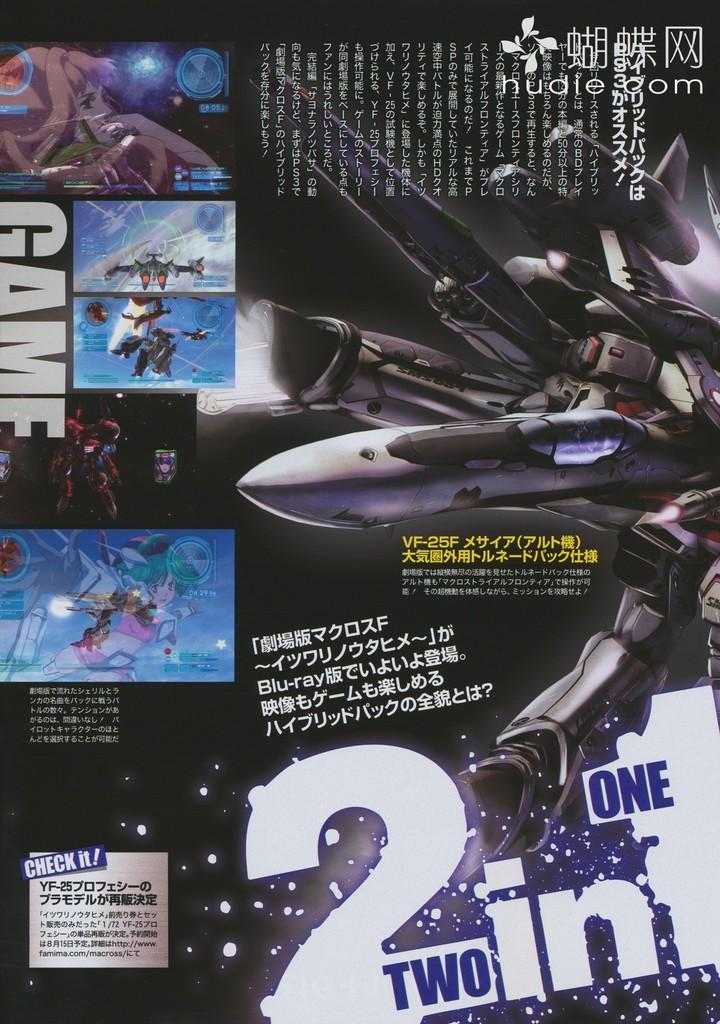<image>
Summarize the visual content of the image. An advertisement features a spaceship and advertises 2 in 1. 